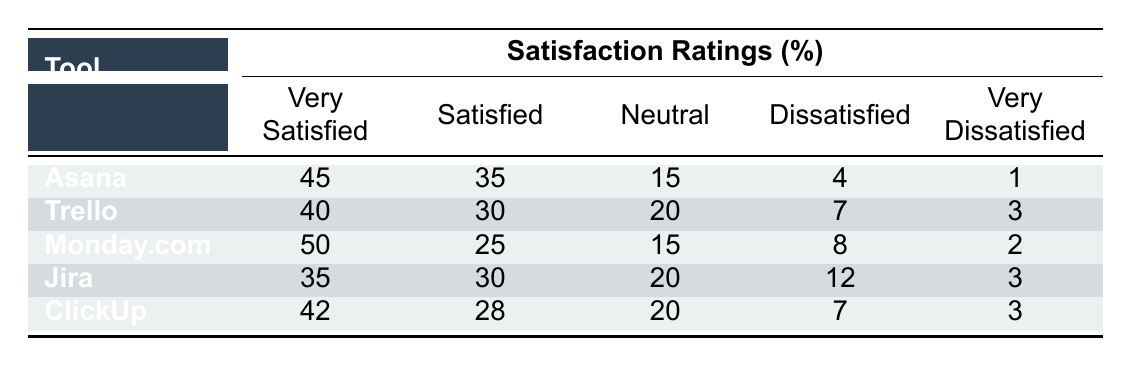What is the satisfaction rating percentage for ClickUp's very satisfied users? The table states that ClickUp has 42% of its users reporting as very satisfied.
Answer: 42% Which tool has the highest percentage of neutral ratings? By examining the table, Trello and ClickUp both have 20% neutral ratings, which is the highest among the listed tools.
Answer: Trello and ClickUp What is the difference in very satisfied ratings between Monday.com and Jira? Monday.com has 50% very satisfied ratings while Jira has 35%. The difference is calculated as 50 - 35 = 15.
Answer: 15 Is it true that Asana has more dissatisfied users than Trello? Asana has 4% dissatisfied users, while Trello has 7%. Since 4 is less than 7, this statement is false.
Answer: No What percentage of users for Monday.com reported being satisfied or very satisfied? Adding Monday.com's very satisfied (50%) and satisfied (25%) ratings gives 50 + 25 = 75%, indicating that 75% of users are either satisfied or very satisfied.
Answer: 75% Which tool has the smallest percentage of very dissatisfied users? By reviewing the table, Asana and Monday.com both have 1% and 2% respectively, meaning Asana has the smallest percentage of very dissatisfied users.
Answer: Asana 